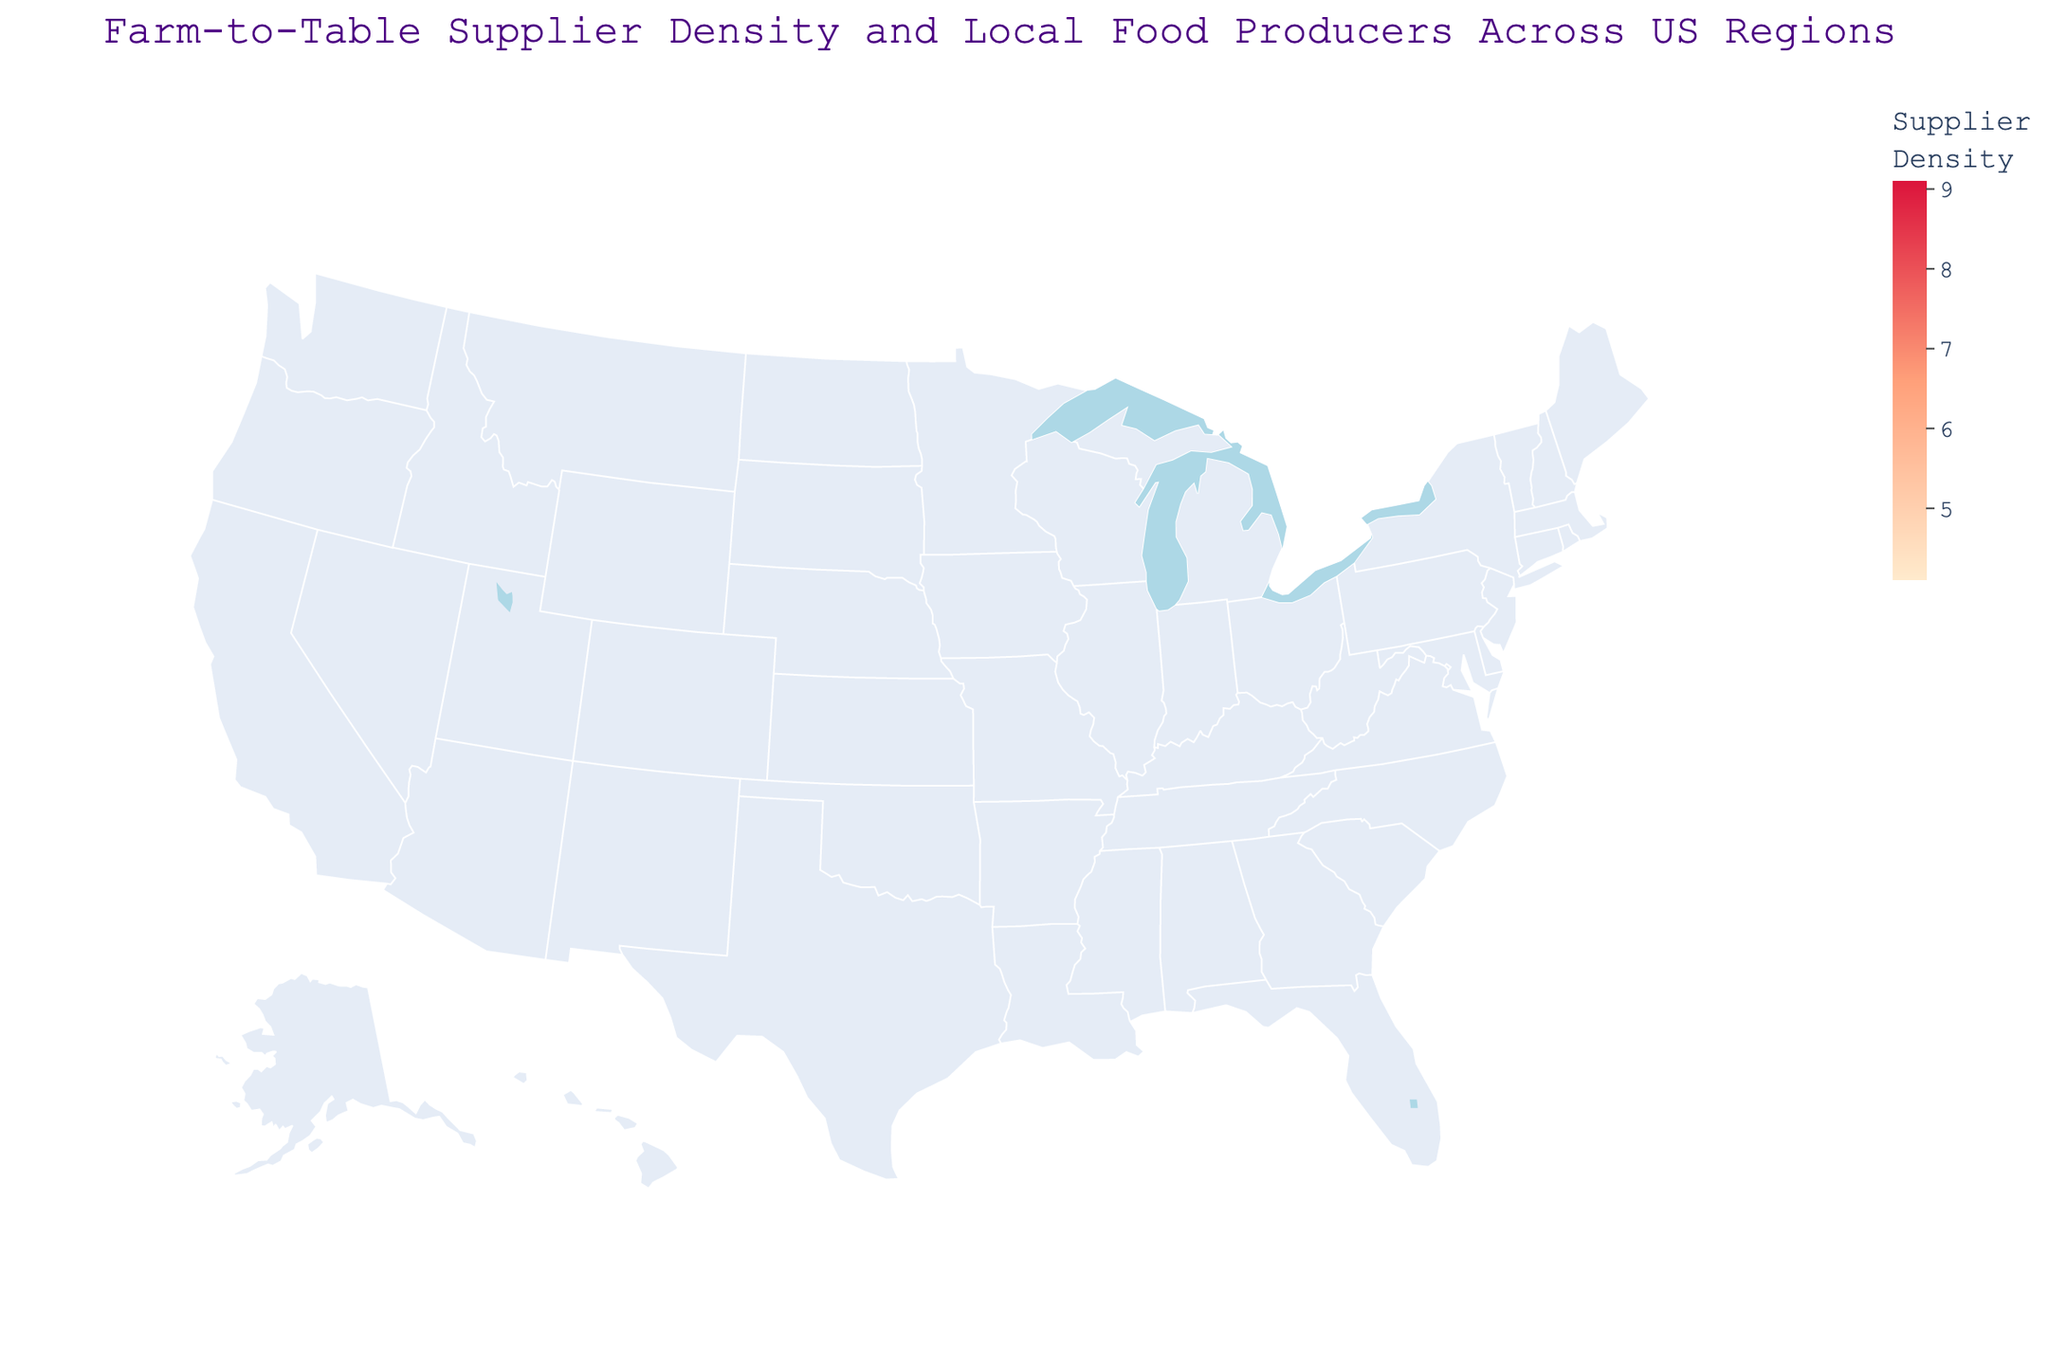What is the title of the figure? The title is usually displayed at the top of the figure. In this case, it can be found just above the plot area.
Answer: Farm-to-Table Supplier Density and Local Food Producers Across US Regions Which region has the highest supplier density? Look at the legend of the color scale and identify which region is shaded the darkest, as that represents the highest density.
Answer: New York How many local food producers are there in California? Hover over California's region on the map to see the hover data, which includes the number of local food producers.
Answer: 201 Which region has the lowest number of local producers? Compare the sizes of the bubbles on the map; the smallest bubble indicates the region with the least number of local producers.
Answer: Alaska What is the supplier density for the Midwest region? Hover over the Midwest region on the map to see the hover data, which includes the supplier density.
Answer: 6.5 How do the supplier densities of the Pacific Northwest and Texas compare? Look at the colors for both regions; the Pacific Northwest should be lighter or darker according to its supplier density compared to Texas.
Answer: Pacific Northwest has higher supplier density than Texas What is the total number of local producers in the Southeast and Southwest combined? Add the number of local producers from the hover data for both the Southeast and Southwest regions (138 + 92).
Answer: 230 Which region has a higher supplier density, New England or Great Lakes? Compare the colors for New England and Great Lakes regions: whichever is darker has the higher density.
Answer: New England What can you infer about the relationship between supplier density and local producer count in California? California has both a high supplier density and a high number of local food producers, indicating a possible positive correlation between supplier density and local producers.
Answer: Positive correlation Where is the color bar situated on the plot, and what does it represent? Check the layout of the plot for the color bar, which typically accompanies a choropleth map to indicate the meaning of colors. It should be on one side or at the bottom, showing supplier density.
Answer: On the right, it represents Supplier Density 